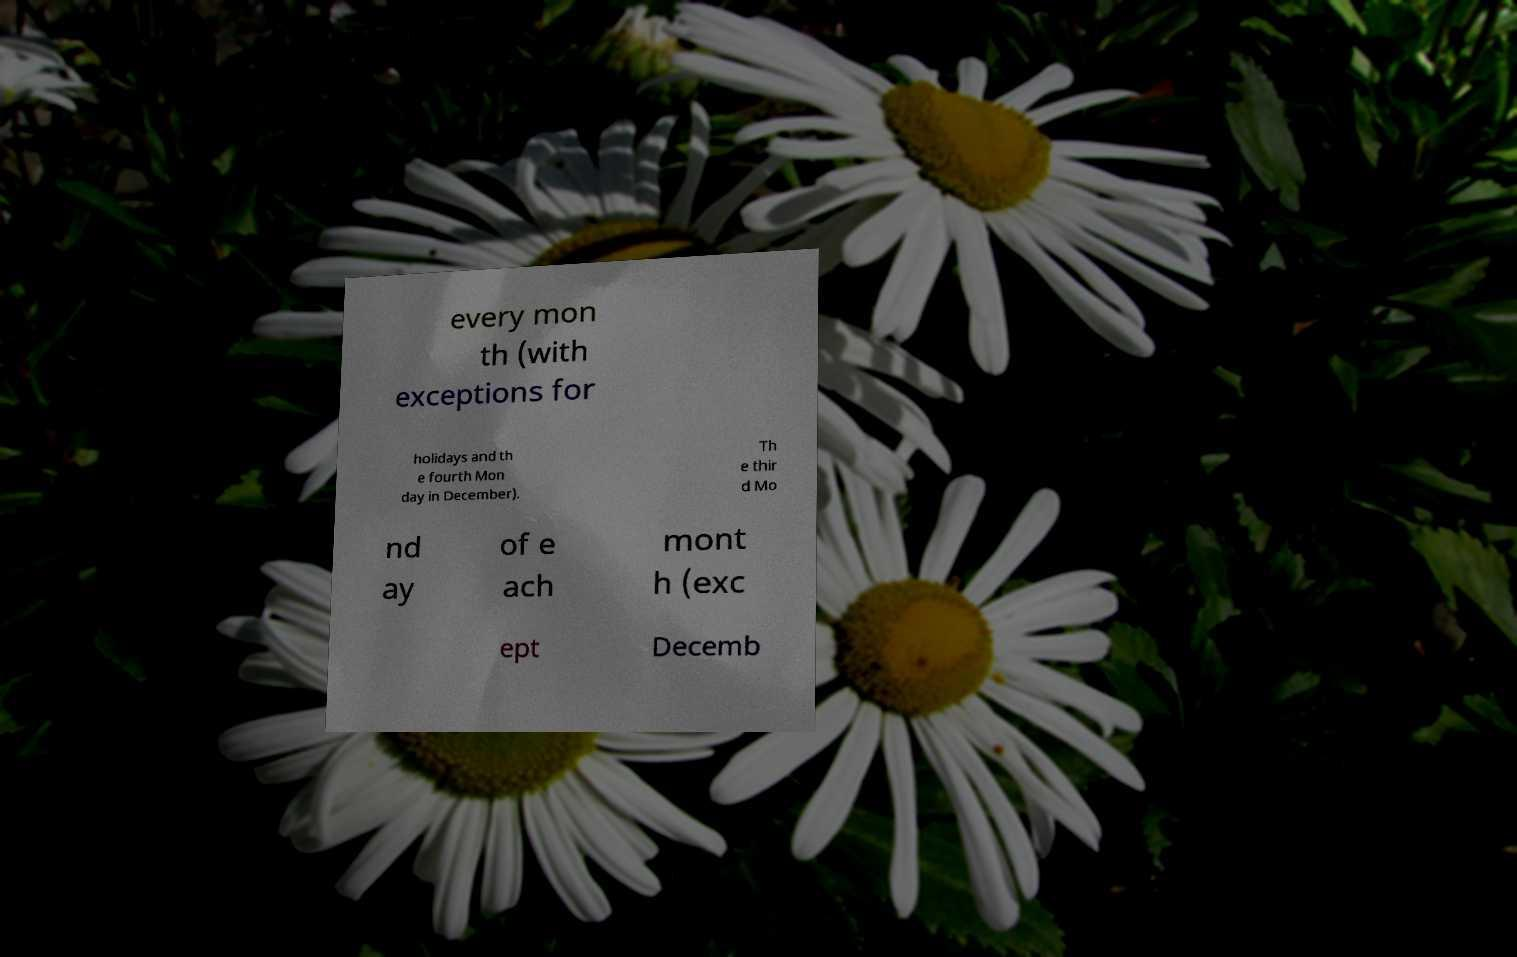Can you accurately transcribe the text from the provided image for me? every mon th (with exceptions for holidays and th e fourth Mon day in December). Th e thir d Mo nd ay of e ach mont h (exc ept Decemb 